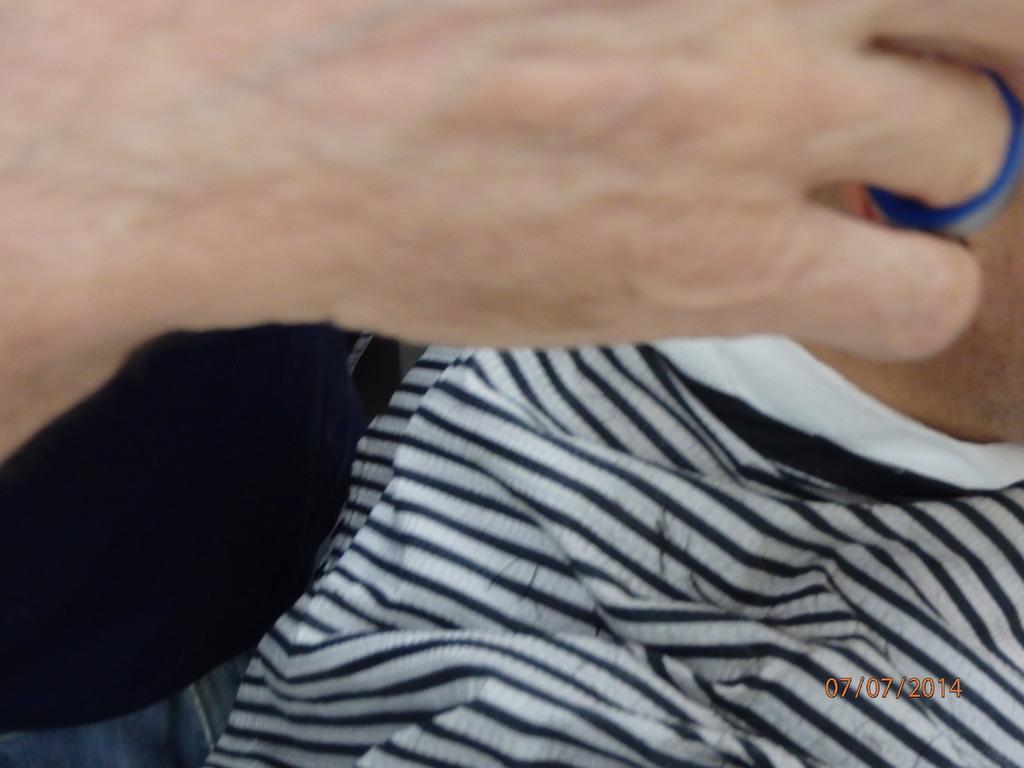In one or two sentences, can you explain what this image depicts? In this image, we can see a cloth. There is a person hand at the top of the image. There is a date in the bottom right of the image. 